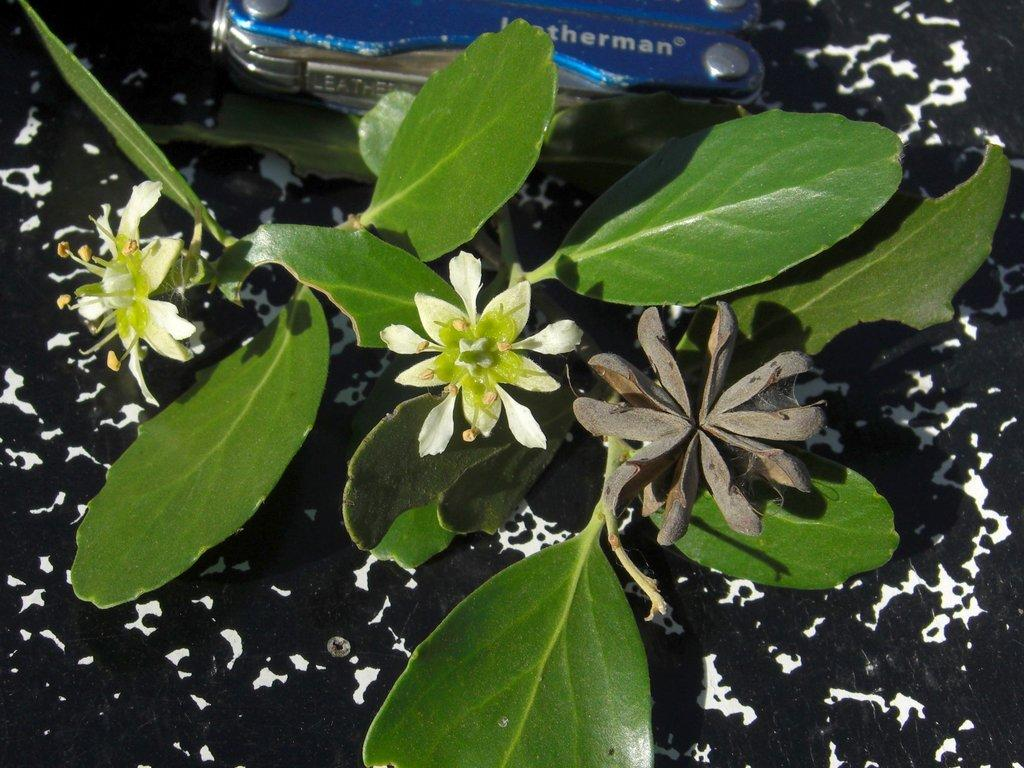What type of plant is visible in the image? There is a plant with flowers in the image. What is the object with text at the top of the image? The object with text at the top of the image is not specified, but it is mentioned that there is an object with text. What is the color scheme of the background in the image? The background of the image is black and white. What type of office furniture can be seen in the image? There is no office furniture present in the image. Is there a ship visible in the image? There is no ship present in the image. 